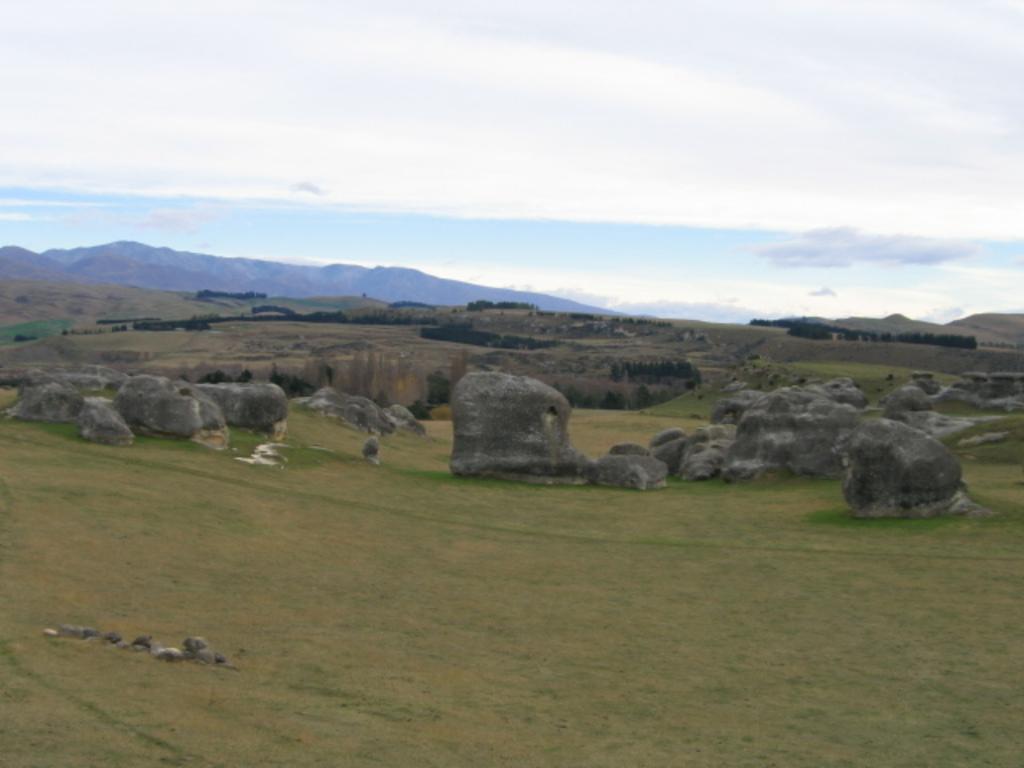Please provide a concise description of this image. This image is clicked outside. There are rocks in the middle. There is sky at the top. There are trees in the middle. 